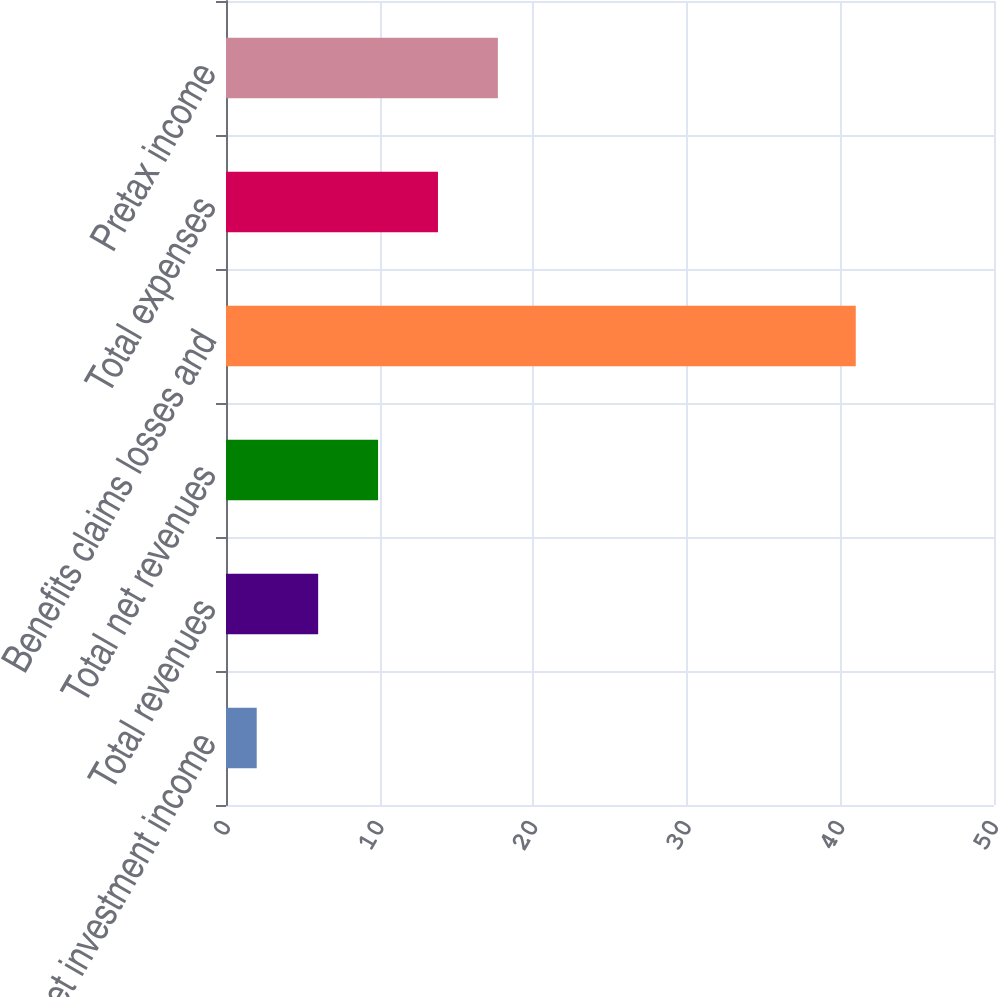Convert chart. <chart><loc_0><loc_0><loc_500><loc_500><bar_chart><fcel>Net investment income<fcel>Total revenues<fcel>Total net revenues<fcel>Benefits claims losses and<fcel>Total expenses<fcel>Pretax income<nl><fcel>2<fcel>6<fcel>9.9<fcel>41<fcel>13.8<fcel>17.7<nl></chart> 